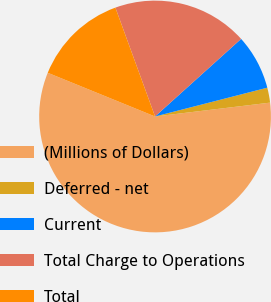Convert chart. <chart><loc_0><loc_0><loc_500><loc_500><pie_chart><fcel>(Millions of Dollars)<fcel>Deferred - net<fcel>Current<fcel>Total Charge to Operations<fcel>Total<nl><fcel>58.06%<fcel>2.09%<fcel>7.68%<fcel>18.88%<fcel>13.28%<nl></chart> 